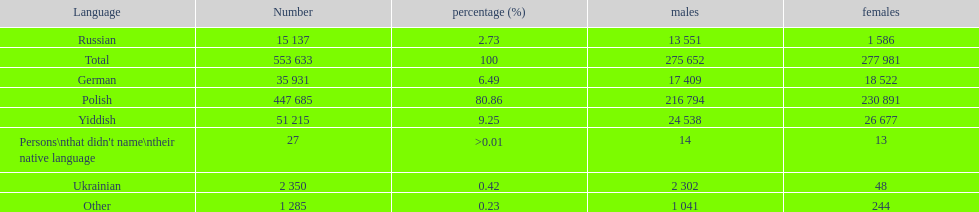How many people didn't name their native language? 27. 